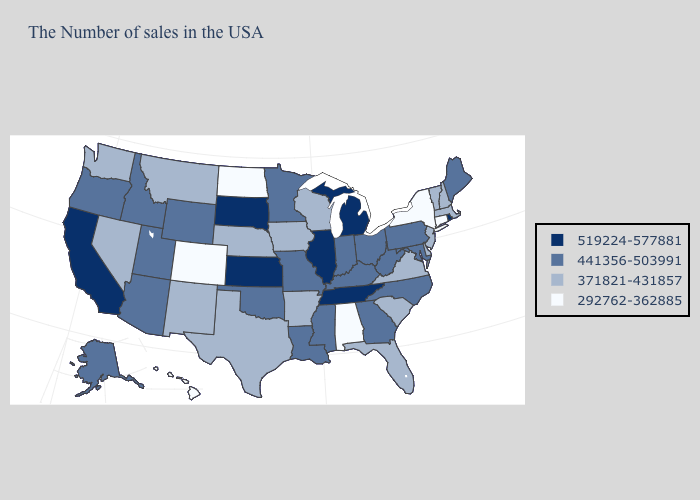Is the legend a continuous bar?
Answer briefly. No. What is the value of Alabama?
Concise answer only. 292762-362885. What is the value of South Carolina?
Be succinct. 371821-431857. Name the states that have a value in the range 519224-577881?
Concise answer only. Rhode Island, Michigan, Tennessee, Illinois, Kansas, South Dakota, California. What is the lowest value in the Northeast?
Give a very brief answer. 292762-362885. Which states have the highest value in the USA?
Quick response, please. Rhode Island, Michigan, Tennessee, Illinois, Kansas, South Dakota, California. Among the states that border Wyoming , which have the highest value?
Keep it brief. South Dakota. What is the value of New Mexico?
Give a very brief answer. 371821-431857. Name the states that have a value in the range 441356-503991?
Give a very brief answer. Maine, Maryland, Pennsylvania, North Carolina, West Virginia, Ohio, Georgia, Kentucky, Indiana, Mississippi, Louisiana, Missouri, Minnesota, Oklahoma, Wyoming, Utah, Arizona, Idaho, Oregon, Alaska. Does New Mexico have a higher value than Hawaii?
Short answer required. Yes. Name the states that have a value in the range 441356-503991?
Answer briefly. Maine, Maryland, Pennsylvania, North Carolina, West Virginia, Ohio, Georgia, Kentucky, Indiana, Mississippi, Louisiana, Missouri, Minnesota, Oklahoma, Wyoming, Utah, Arizona, Idaho, Oregon, Alaska. What is the value of Delaware?
Keep it brief. 371821-431857. What is the value of Massachusetts?
Write a very short answer. 371821-431857. Name the states that have a value in the range 441356-503991?
Quick response, please. Maine, Maryland, Pennsylvania, North Carolina, West Virginia, Ohio, Georgia, Kentucky, Indiana, Mississippi, Louisiana, Missouri, Minnesota, Oklahoma, Wyoming, Utah, Arizona, Idaho, Oregon, Alaska. 